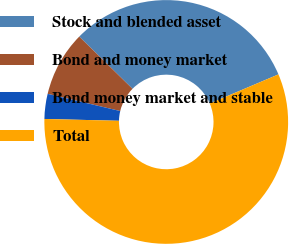Convert chart. <chart><loc_0><loc_0><loc_500><loc_500><pie_chart><fcel>Stock and blended asset<fcel>Bond and money market<fcel>Bond money market and stable<fcel>Total<nl><fcel>31.27%<fcel>8.65%<fcel>3.31%<fcel>56.77%<nl></chart> 